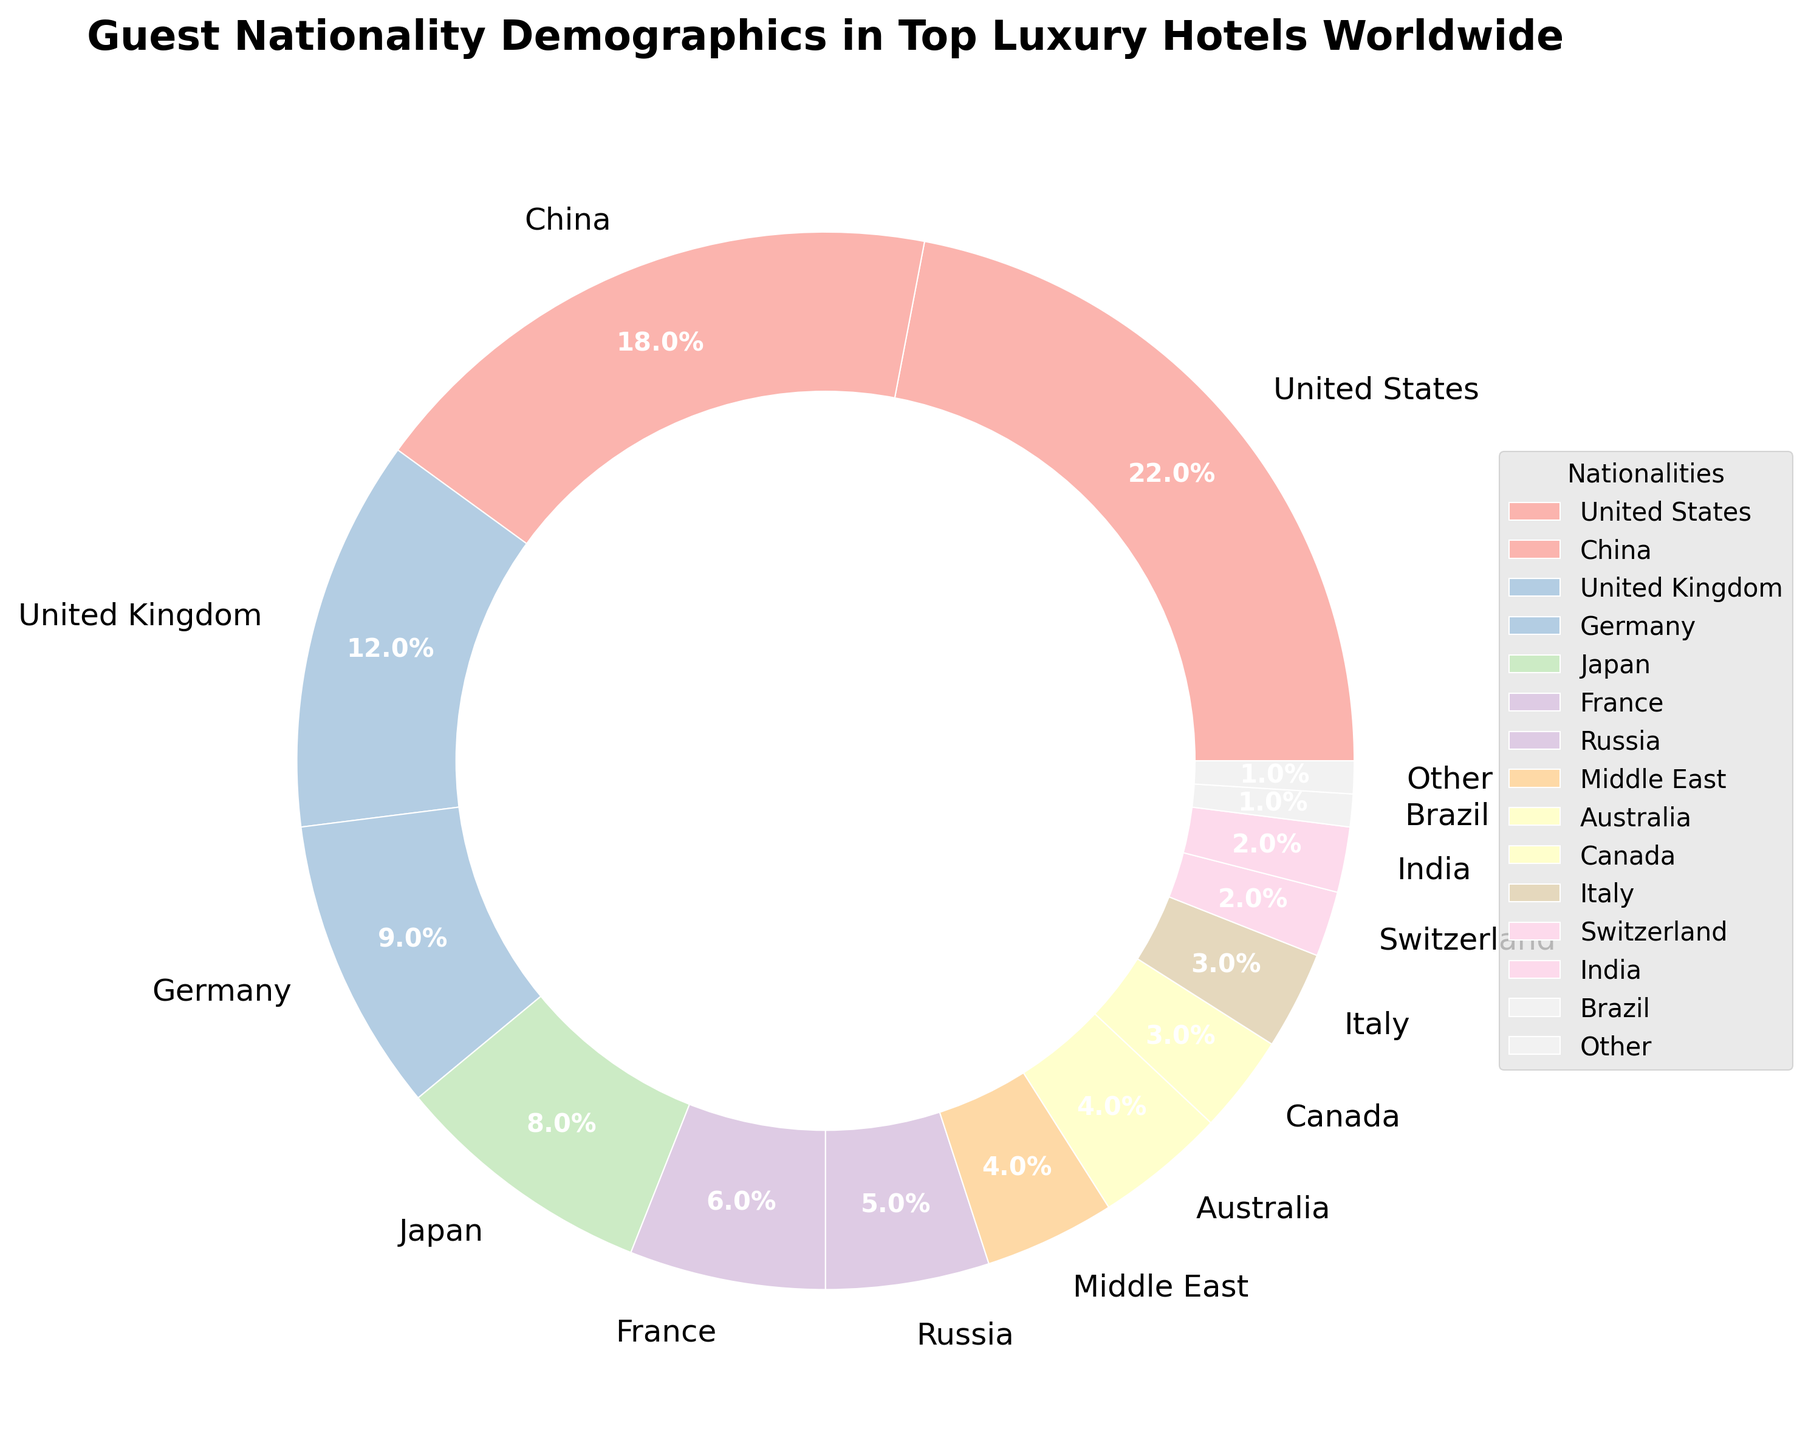What percentage of guests come from the United States and China combined? The percentage of guests from the United States is 22% and from China is 18%. Adding these together gives 22 + 18 = 40%.
Answer: 40% How does the percentage of guests from the United Kingdom compare to that of Germany? The percentage of guests from the United Kingdom is 12%, whereas for Germany it is 9%. Since 12 is greater than 9, the United Kingdom has a higher percentage of guests than Germany.
Answer: The United Kingdom has a higher percentage than Germany Which nationality has the third highest percentage of guests? By noting the percentages, we see the rankings are United States (22%), China (18%), and then the United Kingdom (12%). Hence, the third highest percentage is from the United Kingdom.
Answer: United Kingdom What is the combined percentage of guests from France, Russia, and the Middle East? The percentage of guests from France is 6%, from Russia is 5%, and from the Middle East is 4%. Adding these together gives 6 + 5 + 4 = 15%.
Answer: 15% Which nationalities have an equal percentage of guests, and what is that percentage? The pie chart shows both Australia and the Middle East have 4% each. Therefore, they have an equal percentage of guests.
Answer: Australia and the Middle East, 4% Is the percentage of guests from Canada greater than or less than that from Italy? The percentage of guests from Canada is 3%, while from Italy it is also 3%. Therefore, the percentages are equal.
Answer: Equal What is the difference in guest percentage between the top (United States) and the lowest (Other) categories? The percentage of guests from the United States is 22%, and from the 'Other' category is 1%. The difference is 22 - 1 = 21%.
Answer: 21% List the guest percentages for nationalities from countries with percentages lower than 3%. The nationalities with percentages lower than 3% are Switzerland (2%), India (2%), Brazil (1%), and Other (1%).
Answer: Switzerland 2%, India 2%, Brazil 1%, Other 1% What fraction of the chart represents guests from Japan? Guests from Japan represent 8%. To convert this to a fraction of the entire chart, divide by 100, giving 8/100, which simplifies to 2/25.
Answer: 2/25 Given the title of the chart, suggest why understanding these demographics might be crucial for luxury hotel managers? Understanding these demographics helps hotel managers tailor services and amenities to meet the preferences and expectations of their primary guest nationalities, enhancing guest satisfaction and loyalty.
Answer: Tailoring services and amenities 